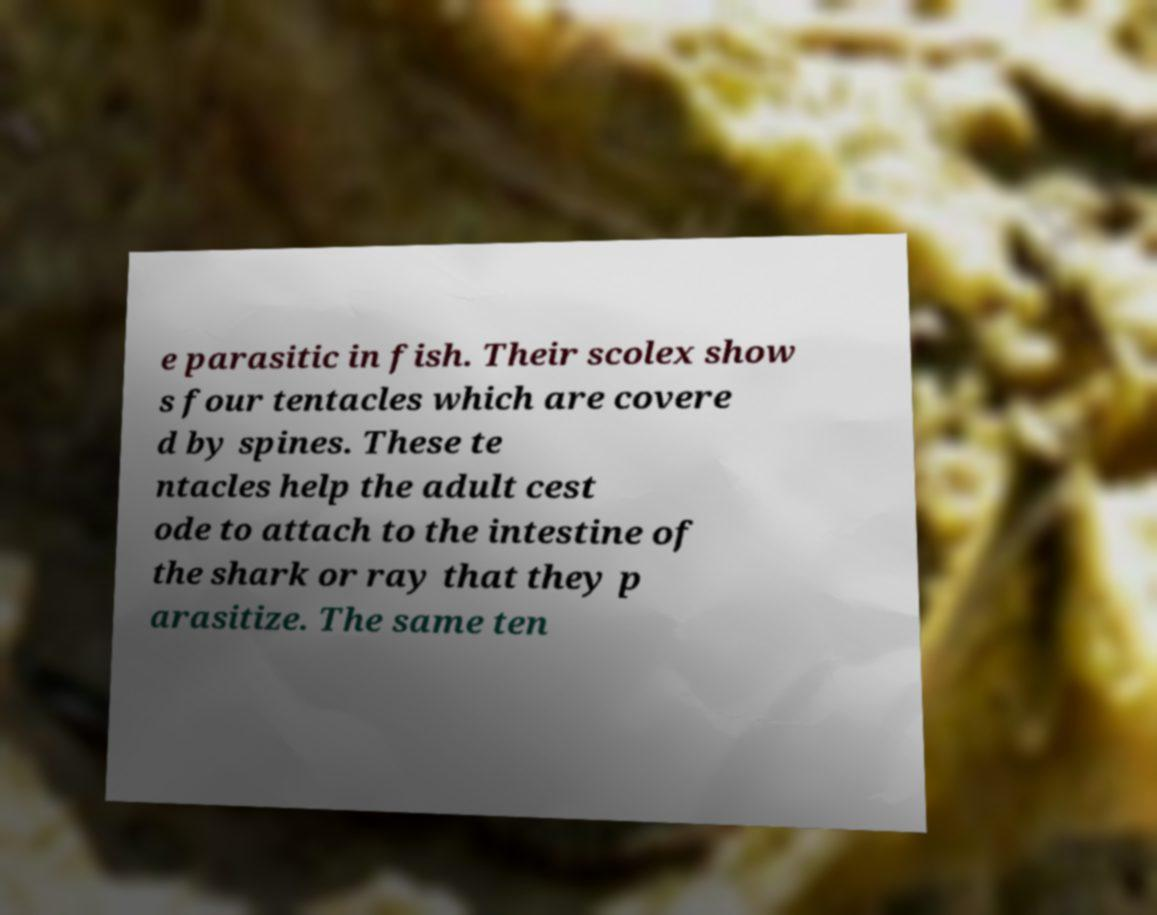I need the written content from this picture converted into text. Can you do that? e parasitic in fish. Their scolex show s four tentacles which are covere d by spines. These te ntacles help the adult cest ode to attach to the intestine of the shark or ray that they p arasitize. The same ten 